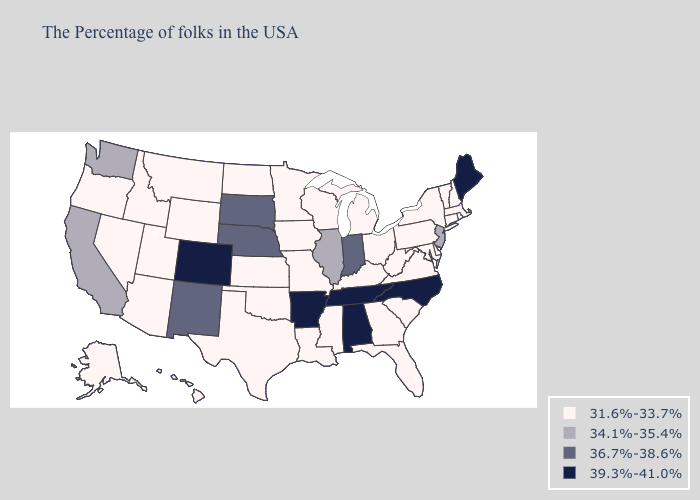What is the lowest value in the South?
Short answer required. 31.6%-33.7%. What is the value of California?
Write a very short answer. 34.1%-35.4%. Name the states that have a value in the range 36.7%-38.6%?
Give a very brief answer. Indiana, Nebraska, South Dakota, New Mexico. What is the lowest value in the West?
Write a very short answer. 31.6%-33.7%. Name the states that have a value in the range 31.6%-33.7%?
Short answer required. Massachusetts, Rhode Island, New Hampshire, Vermont, Connecticut, New York, Delaware, Maryland, Pennsylvania, Virginia, South Carolina, West Virginia, Ohio, Florida, Georgia, Michigan, Kentucky, Wisconsin, Mississippi, Louisiana, Missouri, Minnesota, Iowa, Kansas, Oklahoma, Texas, North Dakota, Wyoming, Utah, Montana, Arizona, Idaho, Nevada, Oregon, Alaska, Hawaii. Name the states that have a value in the range 36.7%-38.6%?
Keep it brief. Indiana, Nebraska, South Dakota, New Mexico. Name the states that have a value in the range 36.7%-38.6%?
Be succinct. Indiana, Nebraska, South Dakota, New Mexico. What is the value of Idaho?
Concise answer only. 31.6%-33.7%. Does Rhode Island have a lower value than Massachusetts?
Keep it brief. No. Does New Hampshire have the lowest value in the USA?
Keep it brief. Yes. Name the states that have a value in the range 34.1%-35.4%?
Be succinct. New Jersey, Illinois, California, Washington. Name the states that have a value in the range 39.3%-41.0%?
Keep it brief. Maine, North Carolina, Alabama, Tennessee, Arkansas, Colorado. What is the highest value in the USA?
Be succinct. 39.3%-41.0%. Among the states that border Georgia , which have the lowest value?
Be succinct. South Carolina, Florida. 